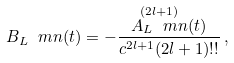<formula> <loc_0><loc_0><loc_500><loc_500>B _ { L } \ m n ( t ) = - \frac { \overset { ( 2 l + 1 ) } { A _ { L } \ m n } ( t ) } { c ^ { 2 l + 1 } ( 2 l + 1 ) ! ! } \, ,</formula> 